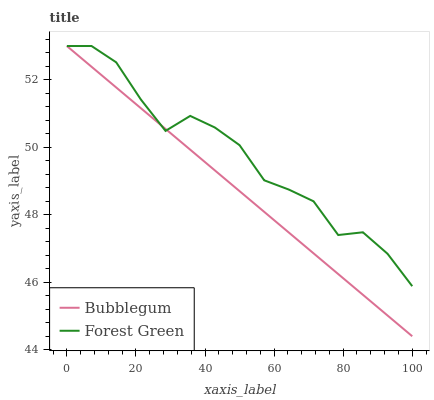Does Bubblegum have the minimum area under the curve?
Answer yes or no. Yes. Does Forest Green have the maximum area under the curve?
Answer yes or no. Yes. Does Bubblegum have the maximum area under the curve?
Answer yes or no. No. Is Bubblegum the smoothest?
Answer yes or no. Yes. Is Forest Green the roughest?
Answer yes or no. Yes. Is Bubblegum the roughest?
Answer yes or no. No. Does Bubblegum have the lowest value?
Answer yes or no. Yes. Does Bubblegum have the highest value?
Answer yes or no. Yes. Does Forest Green intersect Bubblegum?
Answer yes or no. Yes. Is Forest Green less than Bubblegum?
Answer yes or no. No. Is Forest Green greater than Bubblegum?
Answer yes or no. No. 